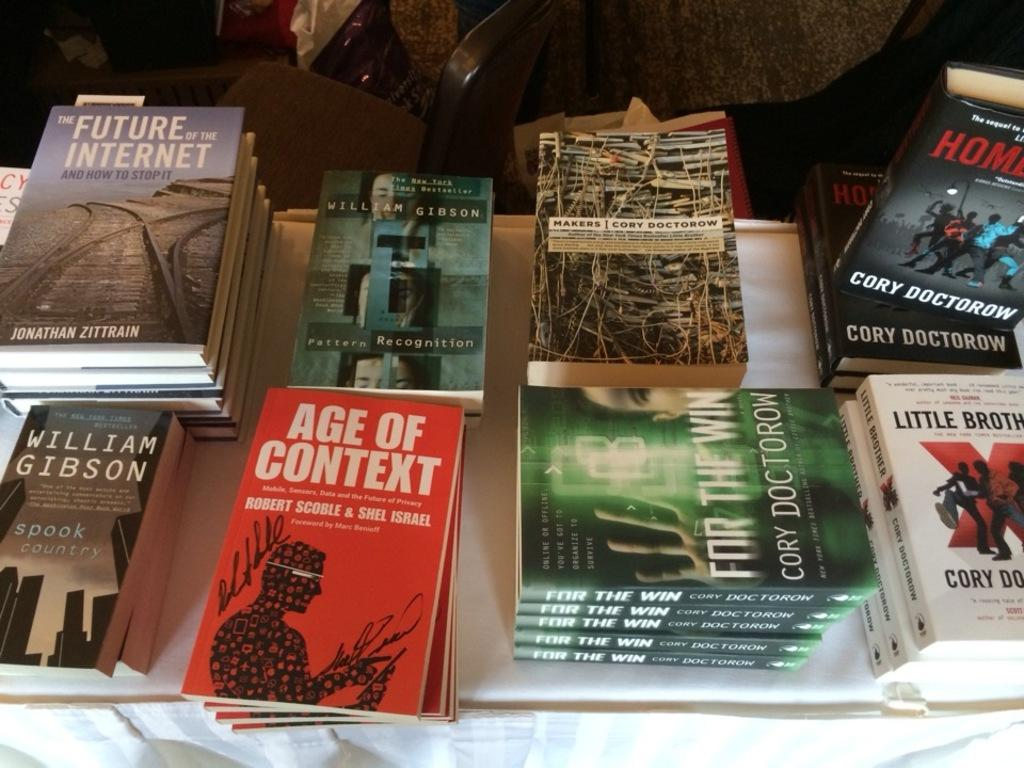<image>
Give a short and clear explanation of the subsequent image. A table is stacked with copies of Age of Context and The Future of the Internet. 